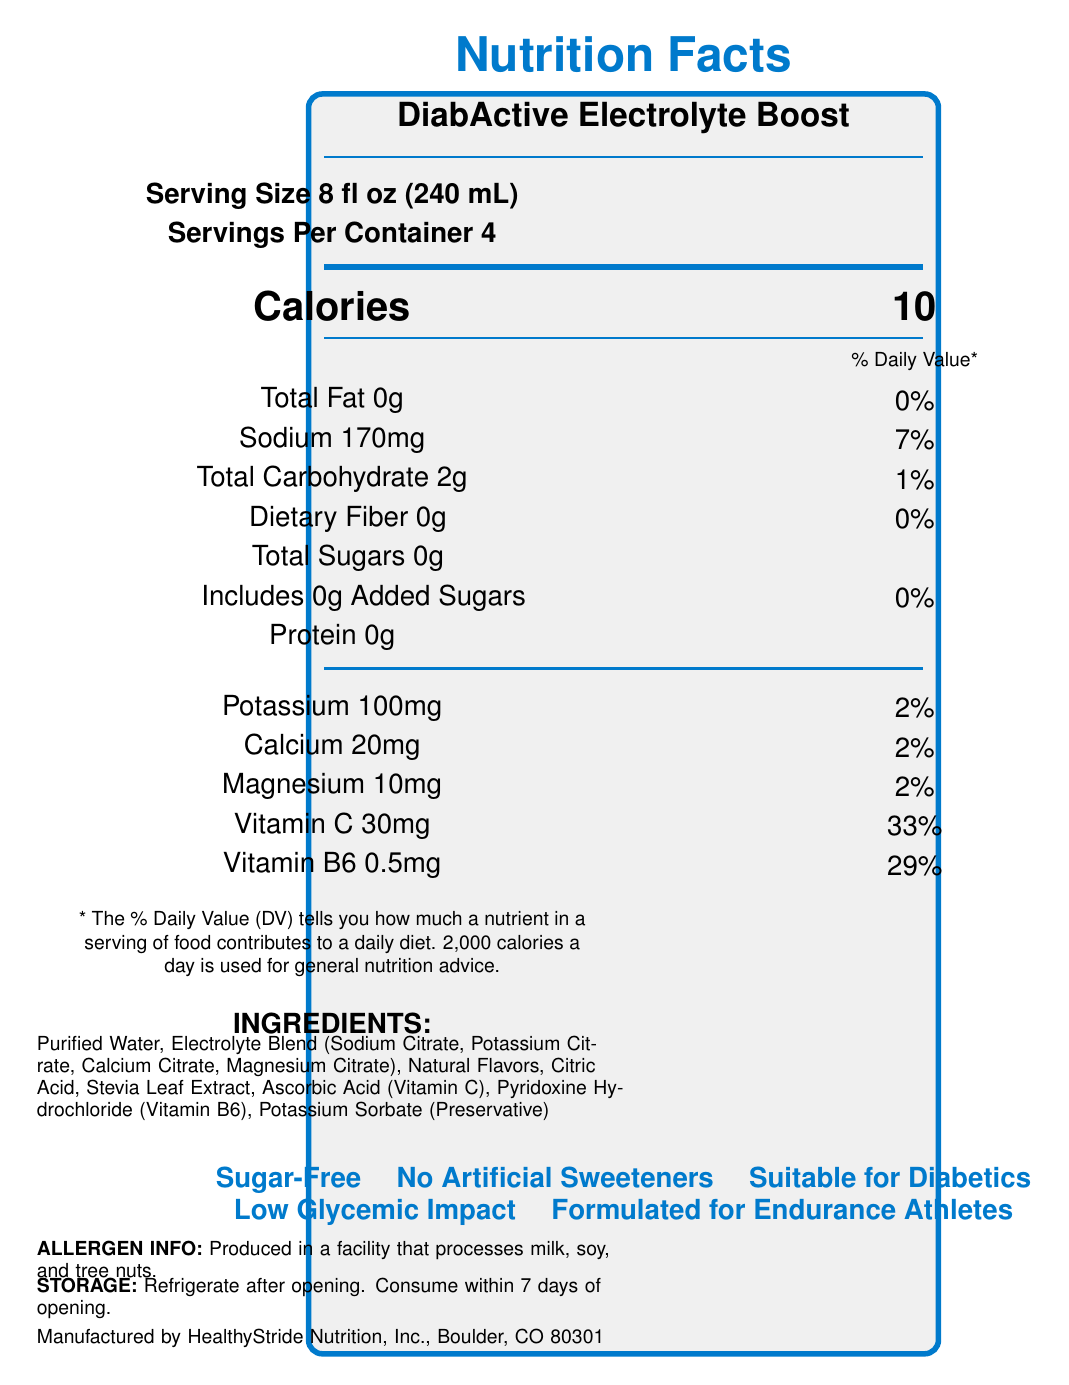what is the serving size? The serving size is specified in the "Serving Size" section of the label.
Answer: 8 fl oz (240 mL) how many servings are in the container? The document states there are 4 servings per container under the "Servings Per Container" section.
Answer: 4 how many calories are in one serving? The calorie information is listed under the "Calories" section, indicating there are 10 calories per serving.
Answer: 10 what is the percentage daily value of vitamin C? The percentage daily value of vitamin C is specified in the nutrients table as 33%.
Answer: 33% how much sodium is in one serving? The sodium content per serving is 170mg as indicated in the nutrients table.
Answer: 170mg which nutrient has the highest daily value percentage? A. Vitamin C B. Sodium C. Potassium D. Vitamin B6 Vitamin C has the highest daily value percentage at 33%, as compared to others listed in the nutrient table.
Answer: A. Vitamin C which of the following is not an ingredient in the product? A. Citric Acid B. High Fructose Corn Syrup C. Stevia Leaf Extract D. Magnesium Citrate High Fructose Corn Syrup is not mentioned in the ingredients list provided.
Answer: B. High Fructose Corn Syrup does the drink contain any added sugars? The document states "Includes 0g Added Sugars" in the nutrients table.
Answer: No can this product be stored at room temperature after opening? The storage instructions specify to "Refrigerate after opening," hence it should not be stored at room temperature after opening.
Answer: No is the product suitable for diabetic athletes? The claim statements explicitly mention that the product is "Suitable for Diabetics."
Answer: Yes what allergens may be present because of production? The allergen info section mentions the product is produced in a facility that processes milk, soy, and tree nuts.
Answer: Milk, soy, and tree nuts does the product contain artificial sweeteners? One of the claim statements asserts "No Artificial Sweeteners."
Answer: No what percentage daily value does vitamin B6 contribute? The percentage daily value of vitamin B6 listed in the nutrients table is 29%.
Answer: 29% what are the main features of the product? The product highlights include its sugar-free formulation, suitability for diabetics, low glycemic impact, and its target audience of endurance athletes.
Answer: DiabActive Electrolyte Boost is a sugar-free, low-calorie electrolyte drink formulated for diabetic and endurance athletes. It provides essential electrolytes, vitamins C and B6, without added sugars or artificial sweeteners. is this product intended to diagnose, treat, cure, or prevent any disease? The disclaimer text clearly states that the product is not intended to diagnose, treat, cure, or prevent any disease.
Answer: No how much potassium does one serving contain? The nutrients table lists the potassium content per serving as 100mg.
Answer: 100mg is this product covered by insurance? The document suggests consulting with a healthcare provider and insurance company to determine if the product qualifies for coverage, therefore it cannot be determined solely based on the visual information in the document.
Answer: Not enough information 